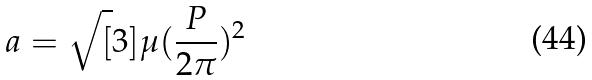<formula> <loc_0><loc_0><loc_500><loc_500>a = \sqrt { [ } 3 ] { \mu ( \frac { P } { 2 \pi } ) ^ { 2 } }</formula> 